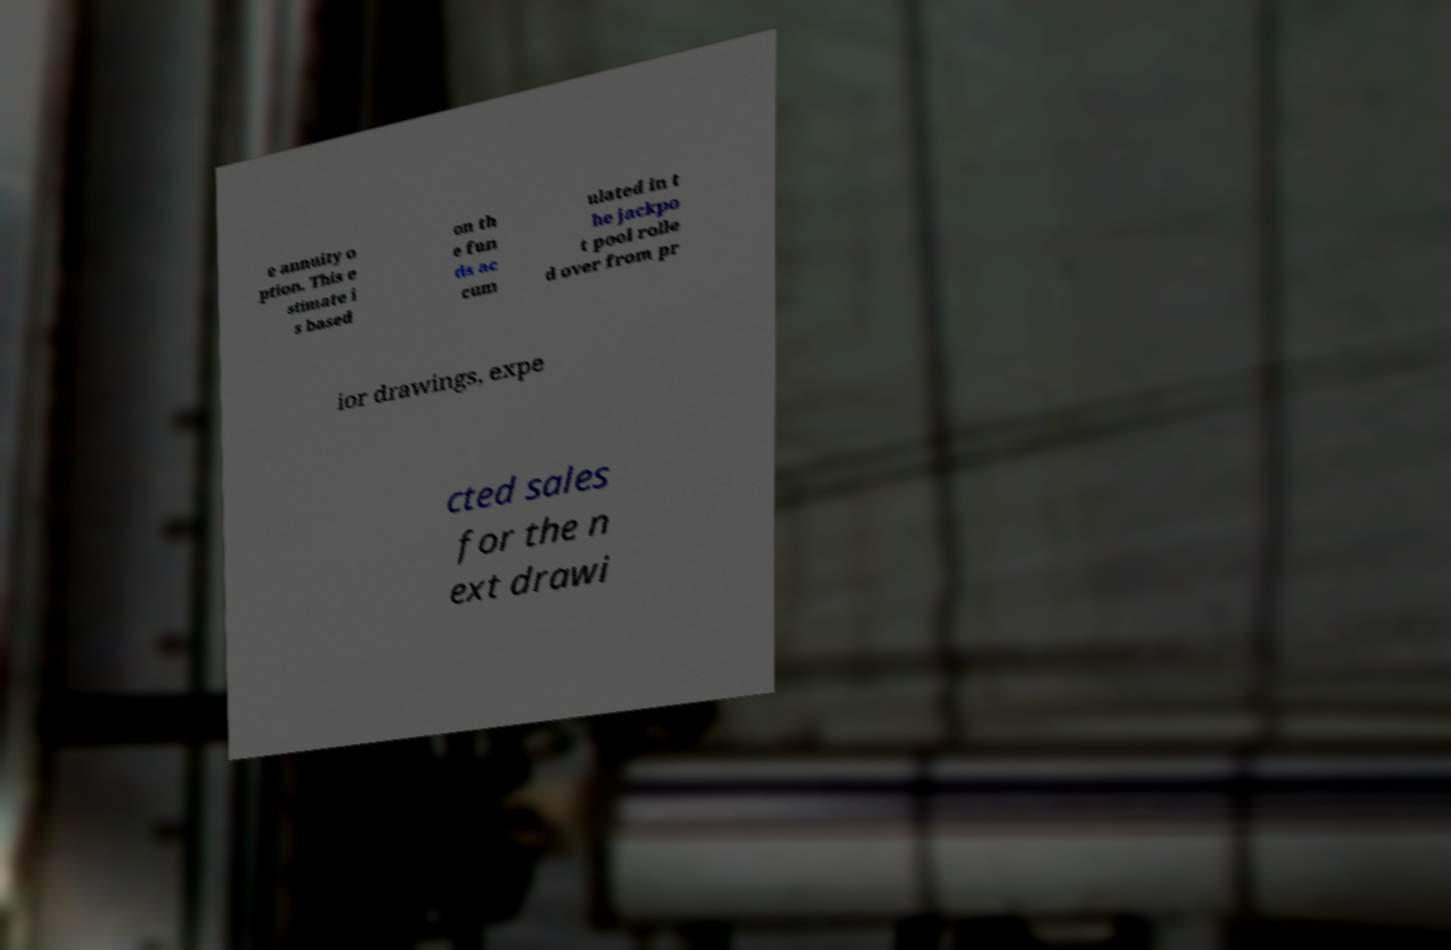For documentation purposes, I need the text within this image transcribed. Could you provide that? e annuity o ption. This e stimate i s based on th e fun ds ac cum ulated in t he jackpo t pool rolle d over from pr ior drawings, expe cted sales for the n ext drawi 